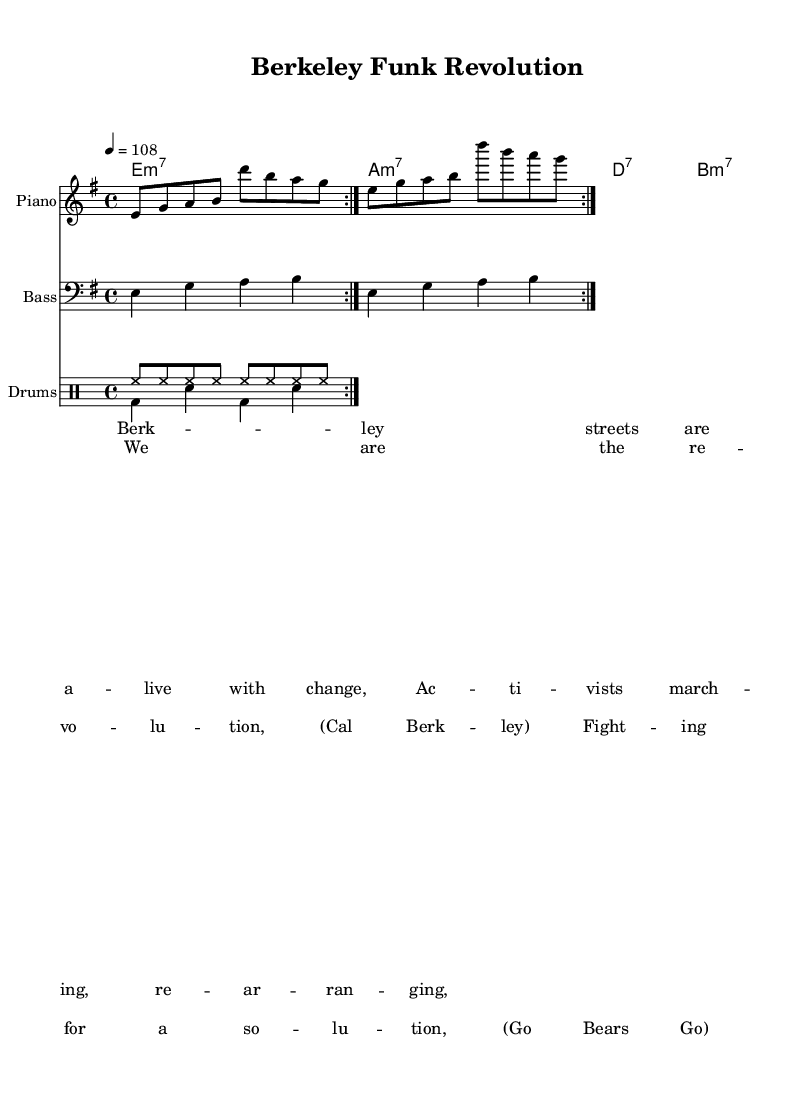What is the key signature of this music? The key signature is determined by the first part of the global section, which shows `\key e \minor`, indicating the music is in the key of E minor.
Answer: E minor What is the time signature of this piece? The time signature is located in the global section as `\time 4/4`, which refers to four beats per measure.
Answer: 4/4 What is the tempo marking of the piece? The tempo is indicated as `\tempo 4 = 108`, meaning the quarter note is the beat and should be played at a speed of 108 beats per minute.
Answer: 108 How many measures are in the verse section? The verse part contains two lines of lyrics, each containing four measures, leading to a total of eight measures for the complete verse section.
Answer: 8 What type of chords are indicated in the chord progression? The chord names show types as `e1:m7`, `a1:m7`, `d1:7`, and `b1:m7`, indicating the chords are a mix of minor seventh and dominant seventh chords, typical for funk music.
Answer: Minor seventh and dominant seventh What instruments are used in this piece? The piece includes three instruments represented in separate staff: Electric Piano, Bass Guitar, and Drums, clearly identified at the start of each staff.
Answer: Electric Piano, Bass Guitar, Drums What is the main theme of the lyrics in this song? The lyrics reflect themes of activism and change, as seen in the lines about Berkeley streets and activists marching, resonating with the campus activism spirit.
Answer: Campus activism 